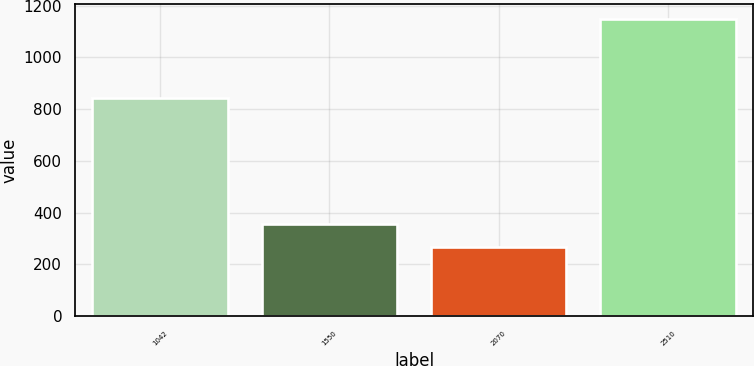Convert chart. <chart><loc_0><loc_0><loc_500><loc_500><bar_chart><fcel>1042<fcel>1550<fcel>2070<fcel>2510<nl><fcel>842<fcel>357.1<fcel>269<fcel>1150<nl></chart> 